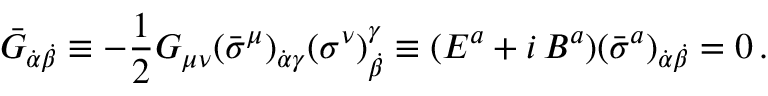Convert formula to latex. <formula><loc_0><loc_0><loc_500><loc_500>\bar { G } _ { \dot { \alpha } \dot { \beta } } \equiv - \frac { 1 } { 2 } G _ { \mu \nu } ( \bar { \sigma } ^ { \mu } ) _ { \dot { \alpha } \gamma } ( \sigma ^ { \nu } ) _ { \dot { \beta } } ^ { \gamma } \equiv ( { E } ^ { a } + i \, { B } ^ { a } ) ( { \bar { \sigma } } ^ { a } ) _ { \dot { \alpha } \dot { \beta } } = 0 \, .</formula> 